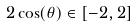<formula> <loc_0><loc_0><loc_500><loc_500>2 \cos ( \theta ) \in [ - 2 , 2 ]</formula> 